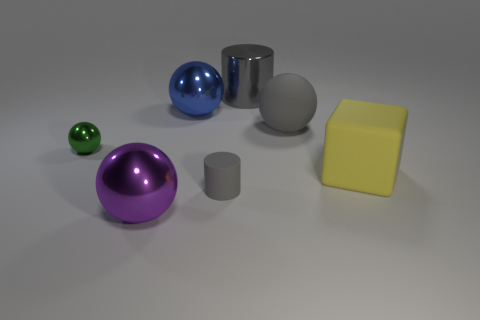Subtract all metal spheres. How many spheres are left? 1 Add 1 tiny matte spheres. How many objects exist? 8 Subtract all green balls. How many balls are left? 3 Subtract all blocks. How many objects are left? 6 Subtract 2 balls. How many balls are left? 2 Subtract all cyan cylinders. How many purple spheres are left? 1 Subtract all yellow matte blocks. Subtract all large shiny spheres. How many objects are left? 4 Add 6 gray matte spheres. How many gray matte spheres are left? 7 Add 1 tiny rubber cylinders. How many tiny rubber cylinders exist? 2 Subtract 0 green cubes. How many objects are left? 7 